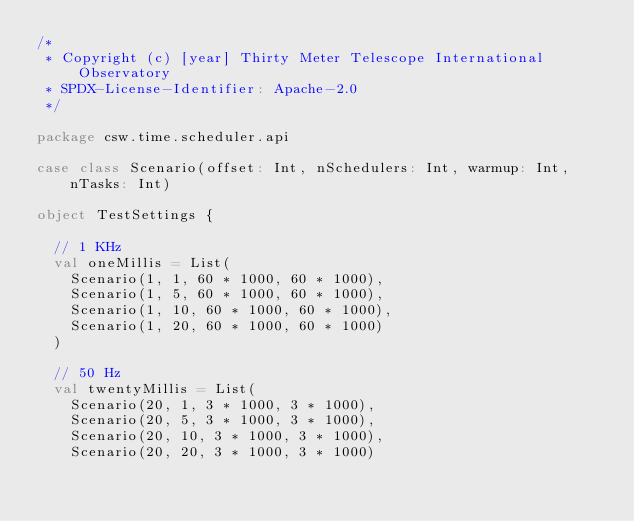<code> <loc_0><loc_0><loc_500><loc_500><_Scala_>/*
 * Copyright (c) [year] Thirty Meter Telescope International Observatory
 * SPDX-License-Identifier: Apache-2.0
 */

package csw.time.scheduler.api

case class Scenario(offset: Int, nSchedulers: Int, warmup: Int, nTasks: Int)

object TestSettings {

  // 1 KHz
  val oneMillis = List(
    Scenario(1, 1, 60 * 1000, 60 * 1000),
    Scenario(1, 5, 60 * 1000, 60 * 1000),
    Scenario(1, 10, 60 * 1000, 60 * 1000),
    Scenario(1, 20, 60 * 1000, 60 * 1000)
  )

  // 50 Hz
  val twentyMillis = List(
    Scenario(20, 1, 3 * 1000, 3 * 1000),
    Scenario(20, 5, 3 * 1000, 3 * 1000),
    Scenario(20, 10, 3 * 1000, 3 * 1000),
    Scenario(20, 20, 3 * 1000, 3 * 1000)</code> 